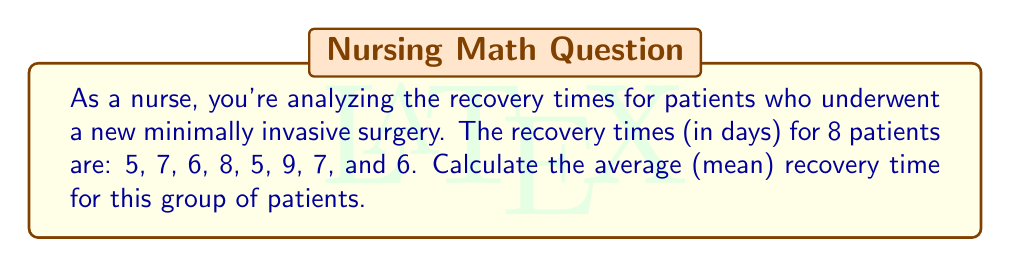Give your solution to this math problem. To calculate the average (mean) recovery time, we need to follow these steps:

1. Sum up all the recovery times:
   $5 + 7 + 6 + 8 + 5 + 9 + 7 + 6 = 53$ days

2. Count the total number of patients:
   There are 8 patients in this group.

3. Divide the sum of recovery times by the number of patients:
   $\text{Average} = \frac{\text{Sum of recovery times}}{\text{Number of patients}}$

   $\text{Average} = \frac{53}{8} = 6.625$ days

Therefore, the average recovery time for patients undergoing this specific medical procedure is 6.625 days.

As a nurse, you can explain to patients that while individual recovery times may vary, on average, patients can expect to recover in about 6.6 days or approximately one week.
Answer: $6.625$ days 